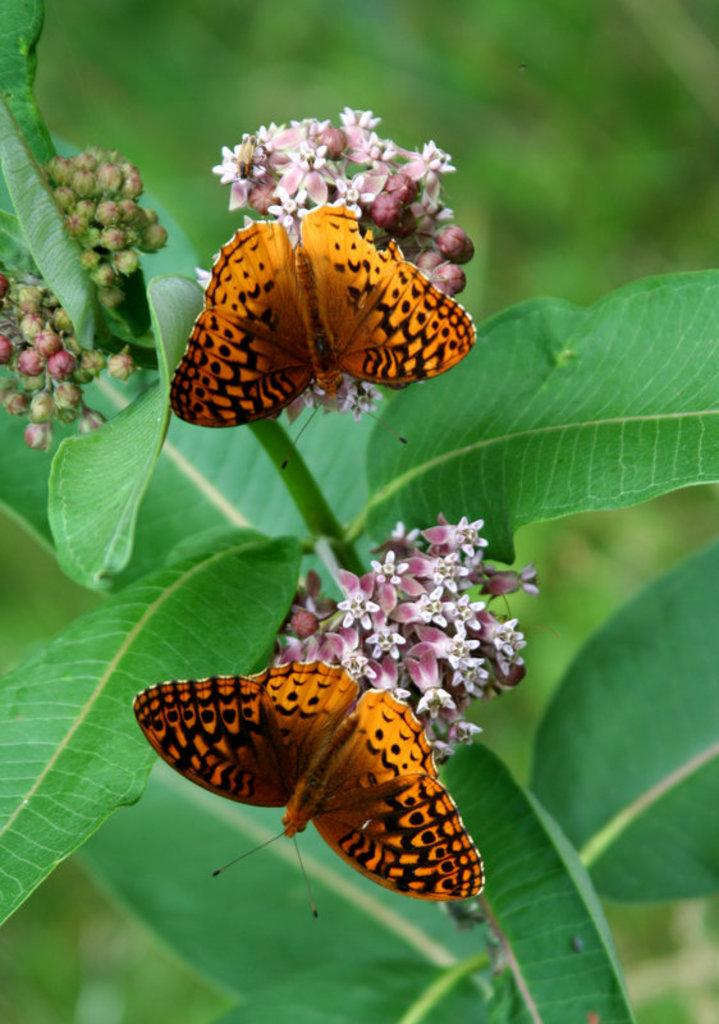What type of animals can be seen in the image? There are butterflies in the image. What type of plants are present in the image? There are flowers and leaves in the image. Are there any unopened flowers visible in the image? Yes, there are buds in the image. What type of slave is depicted in the image? There is no slave present in the image; it features butterflies and plants. What type of coil is wrapped around the butterflies in the image? There is no coil present in the image; it features butterflies and plants. 